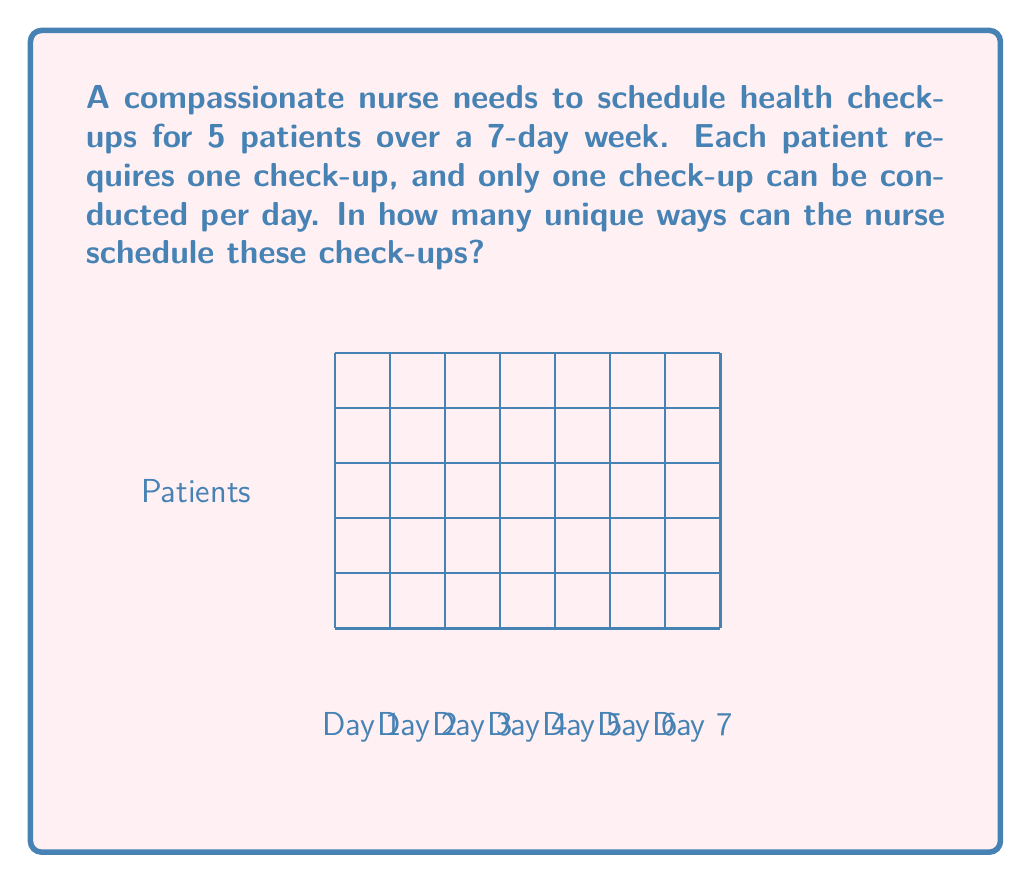Could you help me with this problem? Let's approach this step-by-step:

1) This is a combination problem. We need to choose 5 days out of 7 for the check-ups.

2) The order of selection matters, as each day corresponds to a specific patient. This suggests we should use permutations rather than combinations.

3) We can think of this as filling 5 positions (patients) with 7 possible choices (days) for each position.

4) This is a case of permutation with repetition allowed, as the same day can be chosen for different patients.

5) The formula for permutation with repetition is:

   $$n^r$$

   where $n$ is the number of choices for each position, and $r$ is the number of positions to be filled.

6) In this case, $n = 7$ (days) and $r = 5$ (patients).

7) Therefore, the number of unique ways to schedule the check-ups is:

   $$7^5 = 7 \times 7 \times 7 \times 7 \times 7 = 16,807$$

Thus, there are 16,807 unique ways to schedule the health check-ups.
Answer: $7^5 = 16,807$ 